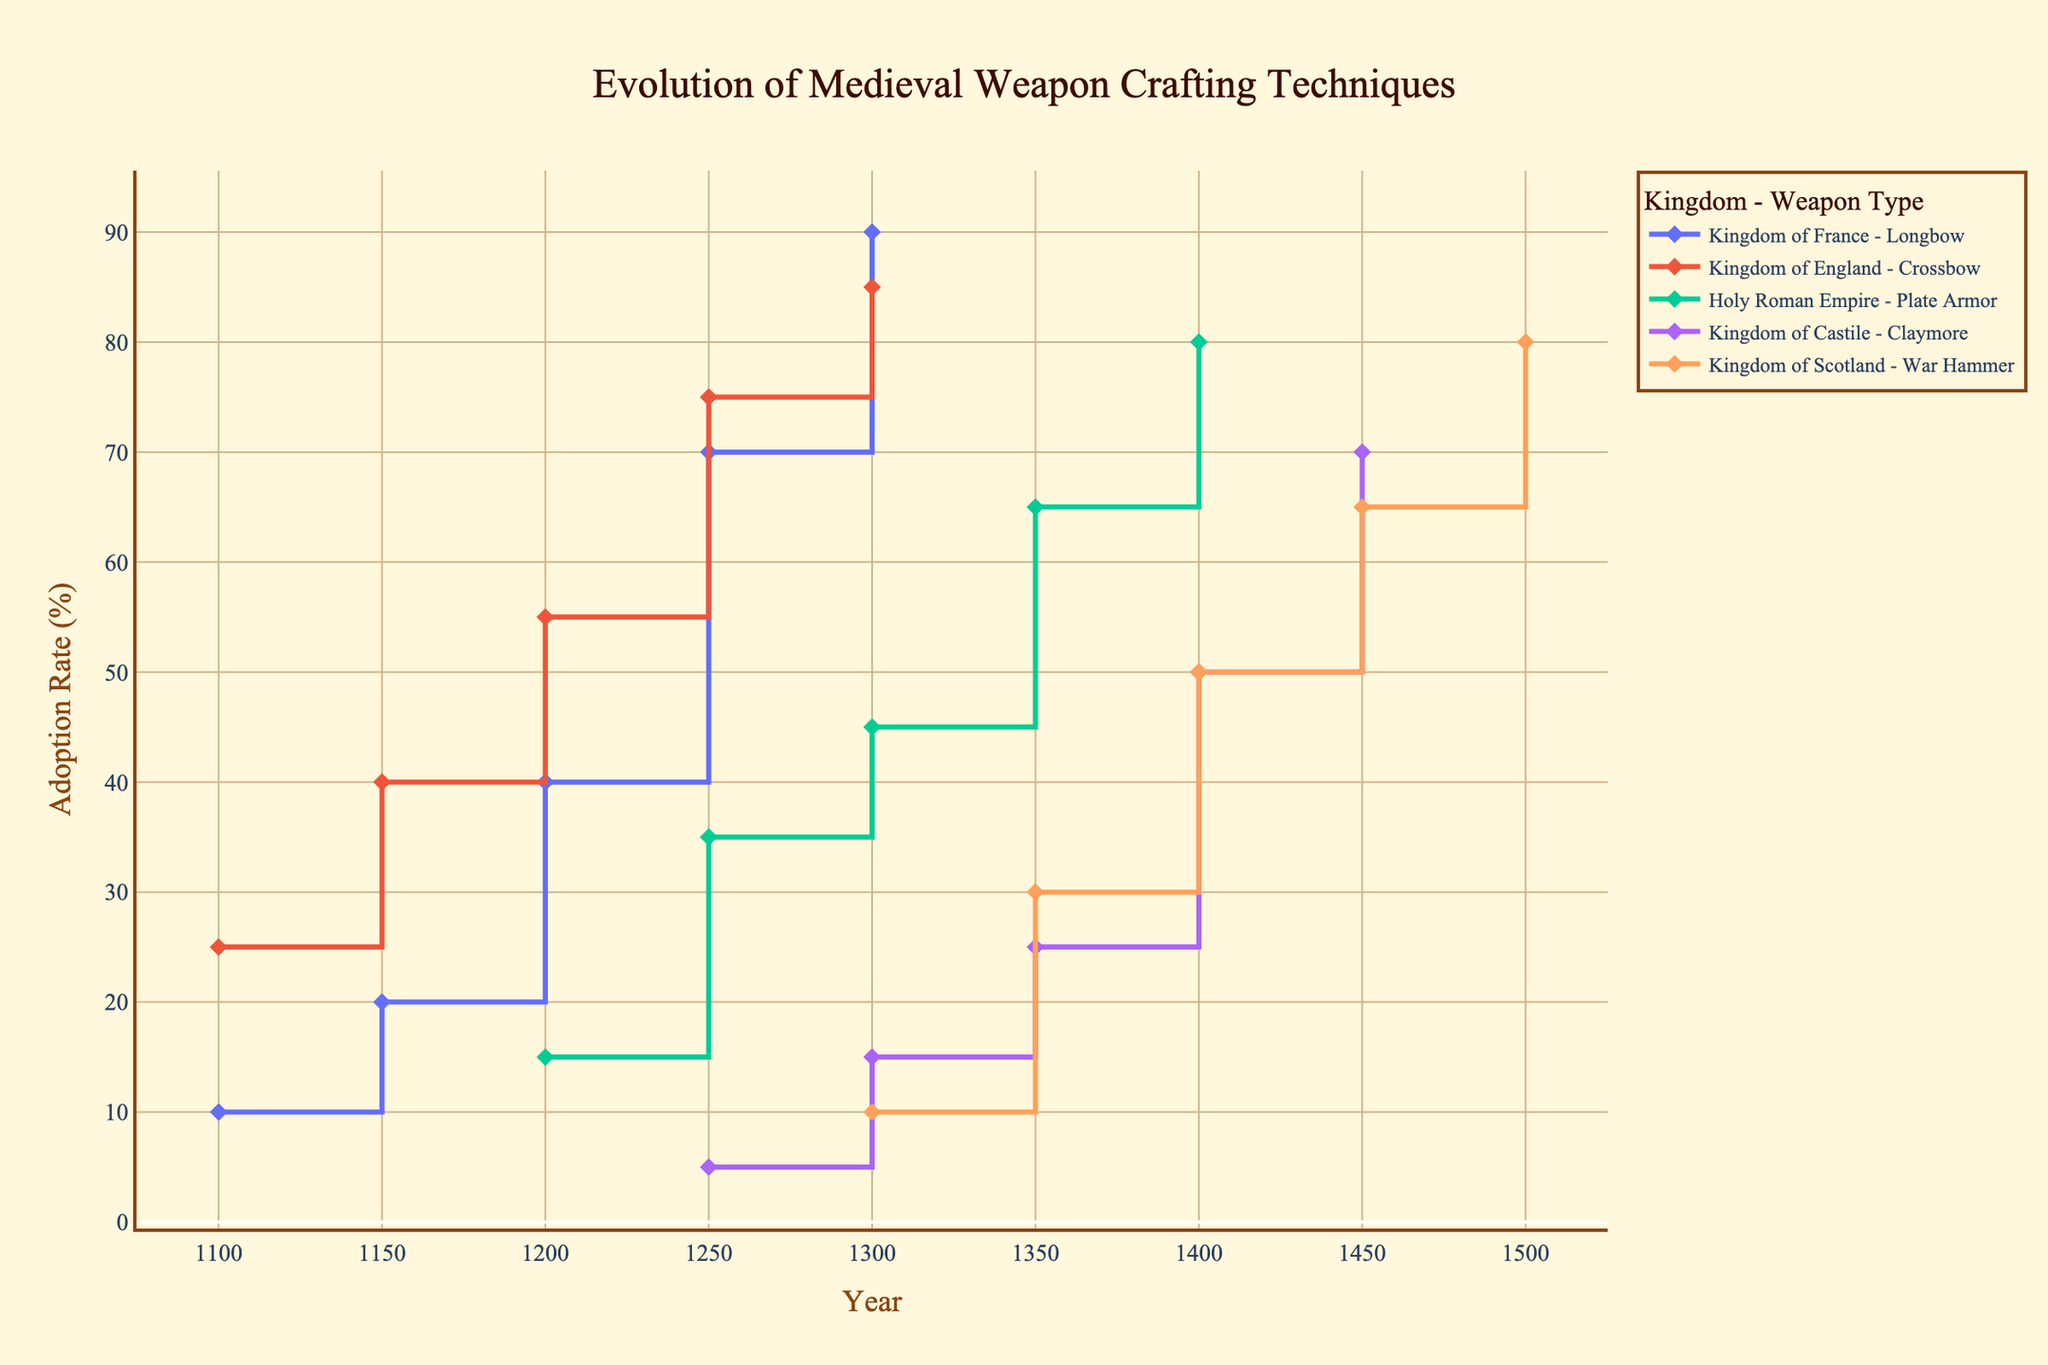What is the overall trend in the adoption rate of longbows in the Kingdom of France? The trend can be determined by observing the line representing the Kingdom of France. From 1100 to 1300, the adoption rate of longbows increases steadily from 10% to 90%.
Answer: Increasing Which kingdom had the highest adoption rate of their respective weapon by 1400? Compare all data points at the year 1400 across all kingdoms. The Kingdom of Castile adopted the Claymore at a rate of 50%, the Holy Roman Empire adopted Plate Armor at 80%, and the Kingdom of Scotland adopted the War Hammer at 50%. The Kingdom of England and Kingdom of France do not have data points for 1400. The highest among these is the Holy Roman Empire at 80%.
Answer: Holy Roman Empire Between 1250 and 1300, which Kingdom showed the greatest increase in adoption rate? Check the increase in adoption rates between these years for all kingdoms. Kingdom of France increased Longbow adoption from 70% to 90% (20% increase). Kingdom of England increased Crossbow adoption from 75% to 85% (10% increase). Holy Roman Empire increased Plate Armor adoption from 35% to 45% (10% increase). Kingdom of Castile increased Claymore adoption from 5% to 15% (10% increase). Kingdom of Scotland started at 1300, so not applicable. The largest increase is 20% for Kingdom of France.
Answer: Kingdom of France How many kingdoms had reached at least a 50% adoption rate of their respective weapon by 1300? Check the adoption rates for all kingdoms at the year 1300. Kingdom of France (Longbow) is at 90%, Kingdom of England (Crossbow) is at 85%, Holy Roman Empire (Plate Armor) is at 45%, and Kingdom of Castile (Claymore) is at 15%. Kingdom of Scotland's War Hammer adoption begins at 1300 at 10%. Only Kingdom of France and Kingdom of England had reached at least 50%.
Answer: 2 Were there any periods where different kingdoms adopted their respective weapons at the same rate? Compare the adoption rates over different periods. At 1300, both Kingdom of England (Crossbow) and Kingdom of France (Longbow) show adoption rates at 85% and 90%, respectively, and none match exactly. At 1450, both Kingdom of Castile (Claymore) and Kingdom of Scotland (War Hammer) show 65% adoption rates. This is the only matching period.
Answer: Yes, 1450 In what year did the Kingdom of England's adoption rate of the Crossbow surpass 50%? Look at the adoption rates for the Kingdom of England. The Crossbow reaches 55% adoption rate by 1200.
Answer: 1200 Which weapon type had the slowest start in terms of adoption rate and how is this depicted in the plot? Identify initial adoption rates for each weapon and compare. The Claymore in the Kingdom of Castile starts at 5% by 1250, which is lower compared to the starting points of other weapons. The slow start is depicted by the relatively flat beginning of the line for the Kingdom of Castile.
Answer: Claymore By how much did the adoption rate for Plate Armor in the Holy Roman Empire increase from 1200 to 1300? The adoption rate for Plate Armor increased from 15% in 1200 to 45% in 1300. The difference is 45% - 15% = 30%.
Answer: 30% 